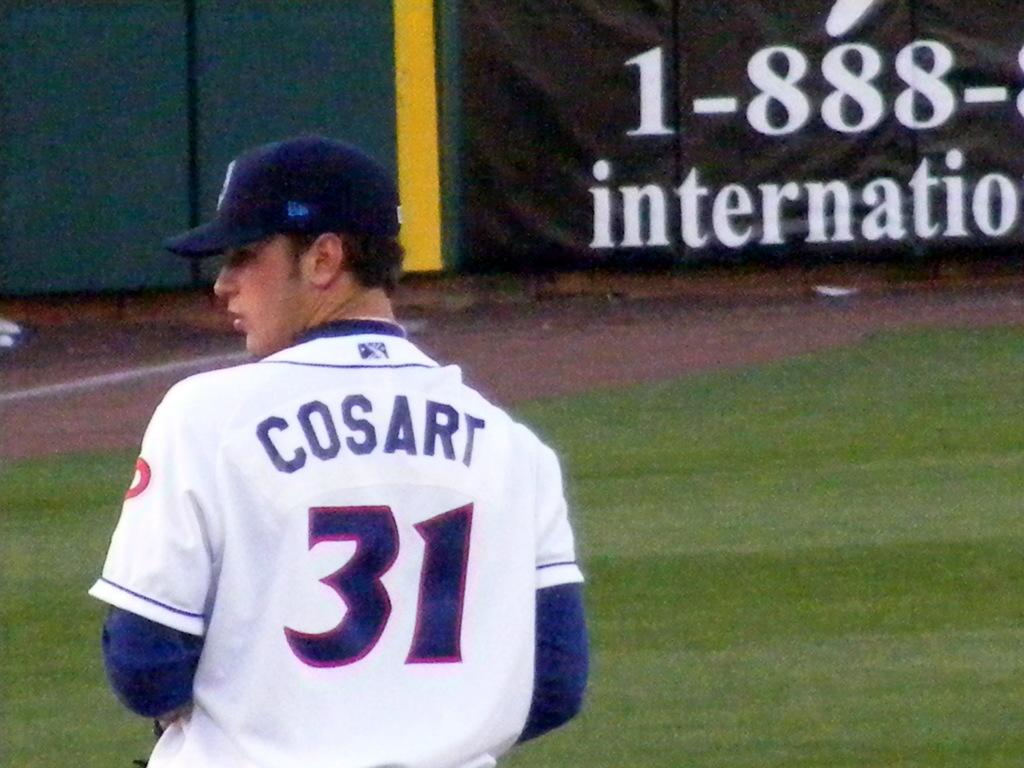Provide a one-sentence caption for the provided image. Baseball player Cosart is on the field looking for the next play. 